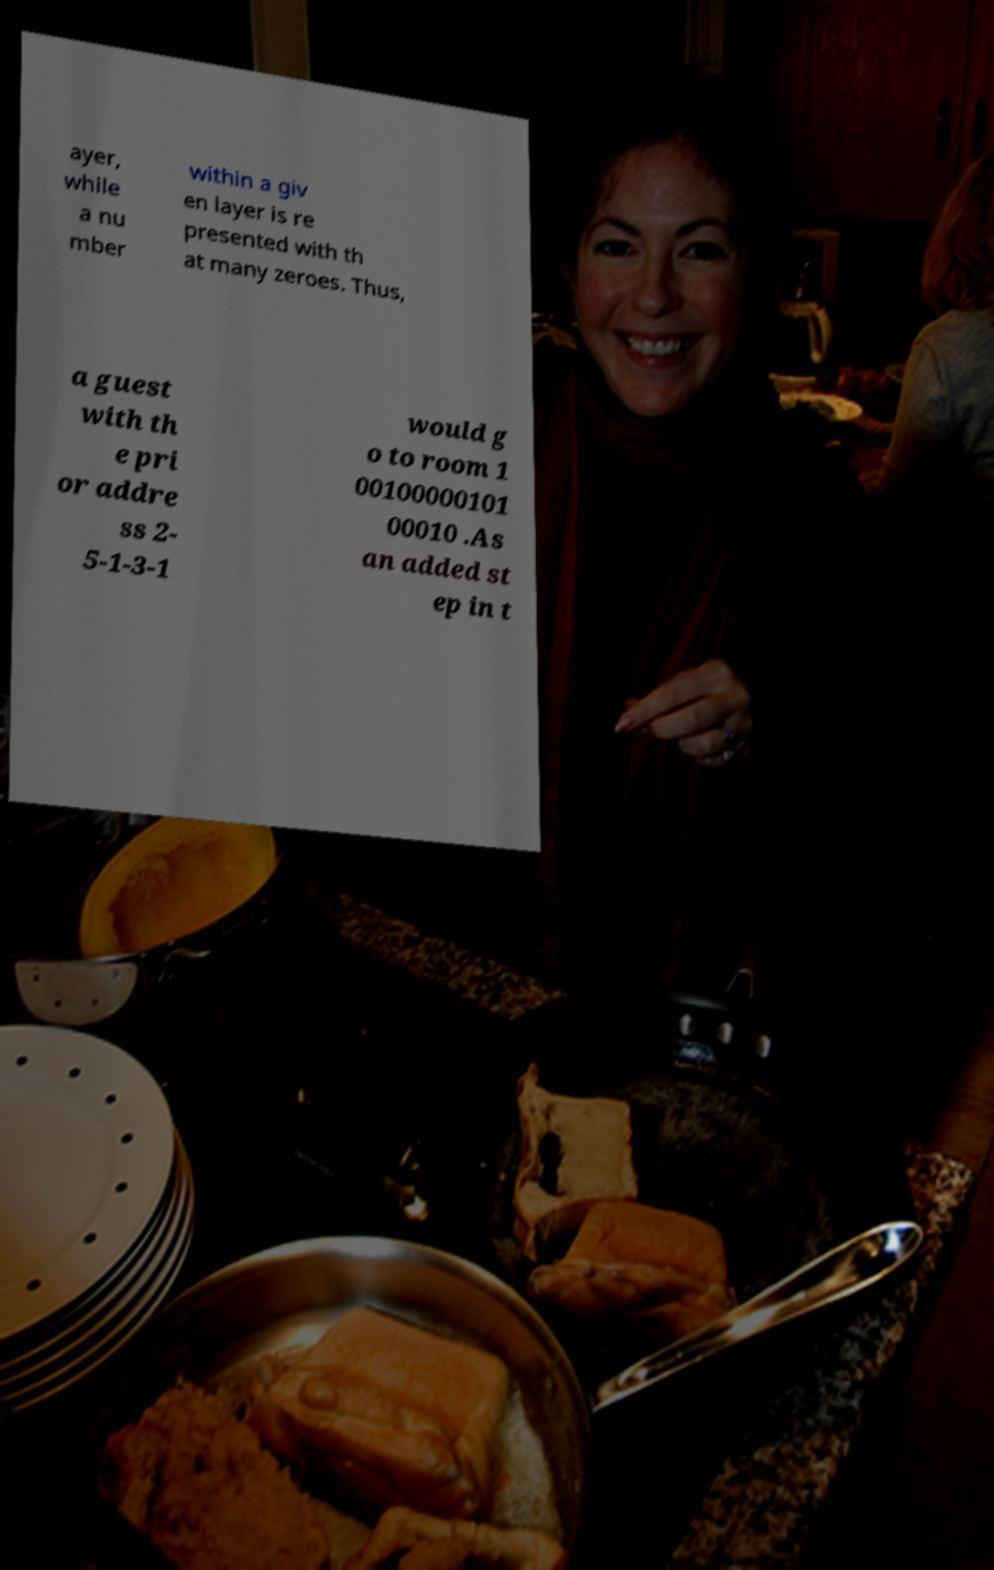Please read and relay the text visible in this image. What does it say? ayer, while a nu mber within a giv en layer is re presented with th at many zeroes. Thus, a guest with th e pri or addre ss 2- 5-1-3-1 would g o to room 1 00100000101 00010 .As an added st ep in t 